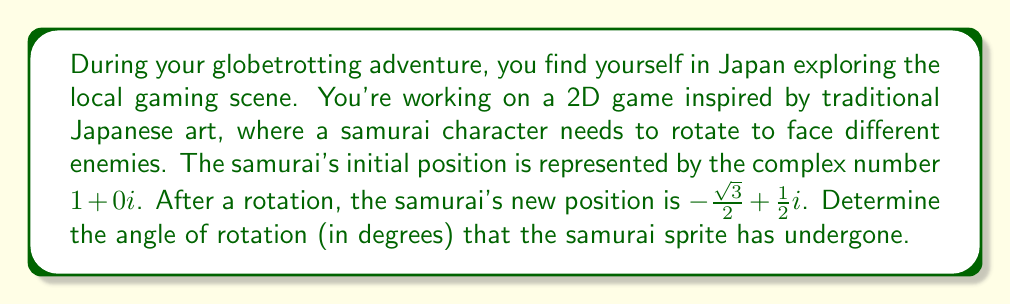Solve this math problem. To solve this problem, we'll use complex numbers and their properties:

1) The initial position is $z_1 = 1 + 0i$
2) The final position is $z_2 = -\frac{\sqrt{3}}{2} + \frac{1}{2}i$

To find the angle of rotation, we can divide $z_2$ by $z_1$ and then find the argument of the resulting complex number:

$$\frac{z_2}{z_1} = \frac{-\frac{\sqrt{3}}{2} + \frac{1}{2}i}{1 + 0i} = -\frac{\sqrt{3}}{2} + \frac{1}{2}i$$

This complex number represents the rotation. To find its argument (angle), we can use the arctangent function:

$$\theta = \arctan(\frac{\text{Im}}{\text{Re}}) = \arctan(\frac{\frac{1}{2}}{-\frac{\sqrt{3}}{2}}) = \arctan(-\frac{1}{\sqrt{3}})$$

However, we need to be careful here. The arctangent function only gives values between $-\frac{\pi}{2}$ and $\frac{\pi}{2}$. In this case, since both the real and imaginary parts are negative, we're in the third quadrant. We need to add $\pi$ to our result:

$$\theta = \arctan(-\frac{1}{\sqrt{3}}) + \pi$$

Now, let's calculate:

$$\theta = \arctan(-\frac{1}{\sqrt{3}}) + \pi \approx -0.5236 + 3.1416 \approx 2.6180 \text{ radians}$$

To convert to degrees, we multiply by $\frac{180}{\pi}$:

$$2.6180 \times \frac{180}{\pi} \approx 150°$$

Therefore, the samurai sprite has rotated approximately 150 degrees counterclockwise.
Answer: The angle of rotation for the samurai sprite is approximately 150°. 